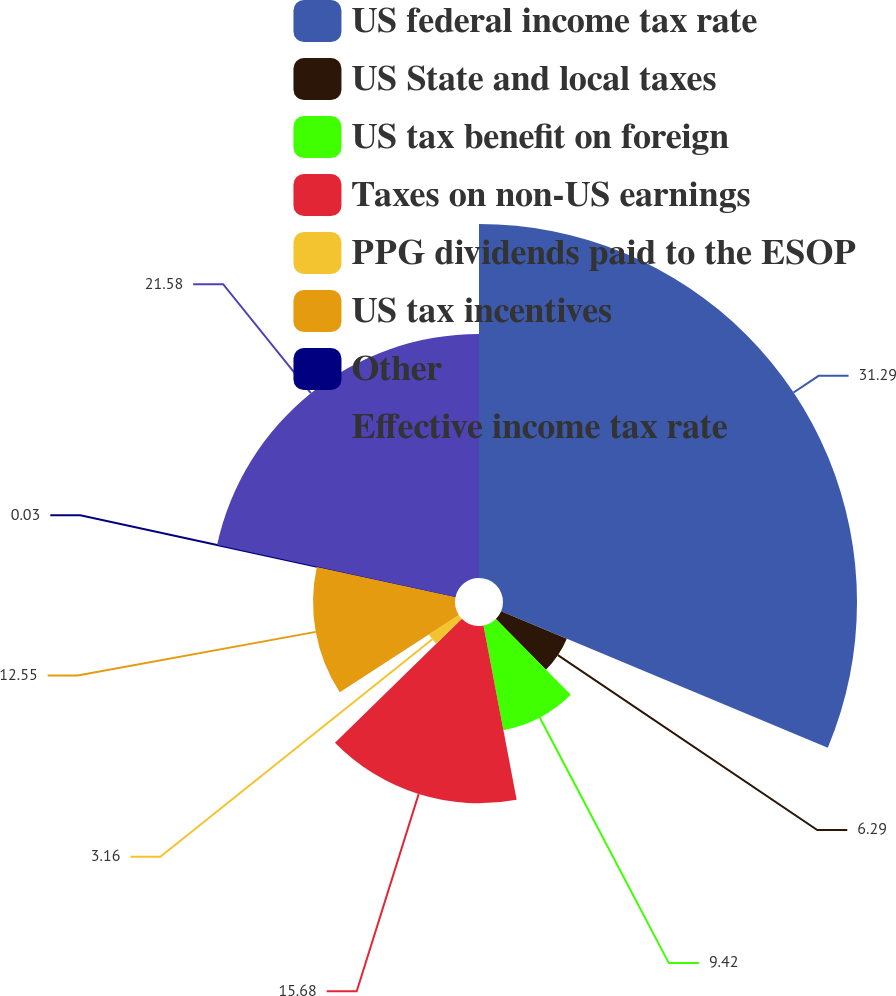Convert chart to OTSL. <chart><loc_0><loc_0><loc_500><loc_500><pie_chart><fcel>US federal income tax rate<fcel>US State and local taxes<fcel>US tax benefit on foreign<fcel>Taxes on non-US earnings<fcel>PPG dividends paid to the ESOP<fcel>US tax incentives<fcel>Other<fcel>Effective income tax rate<nl><fcel>31.3%<fcel>6.29%<fcel>9.42%<fcel>15.68%<fcel>3.16%<fcel>12.55%<fcel>0.03%<fcel>21.58%<nl></chart> 